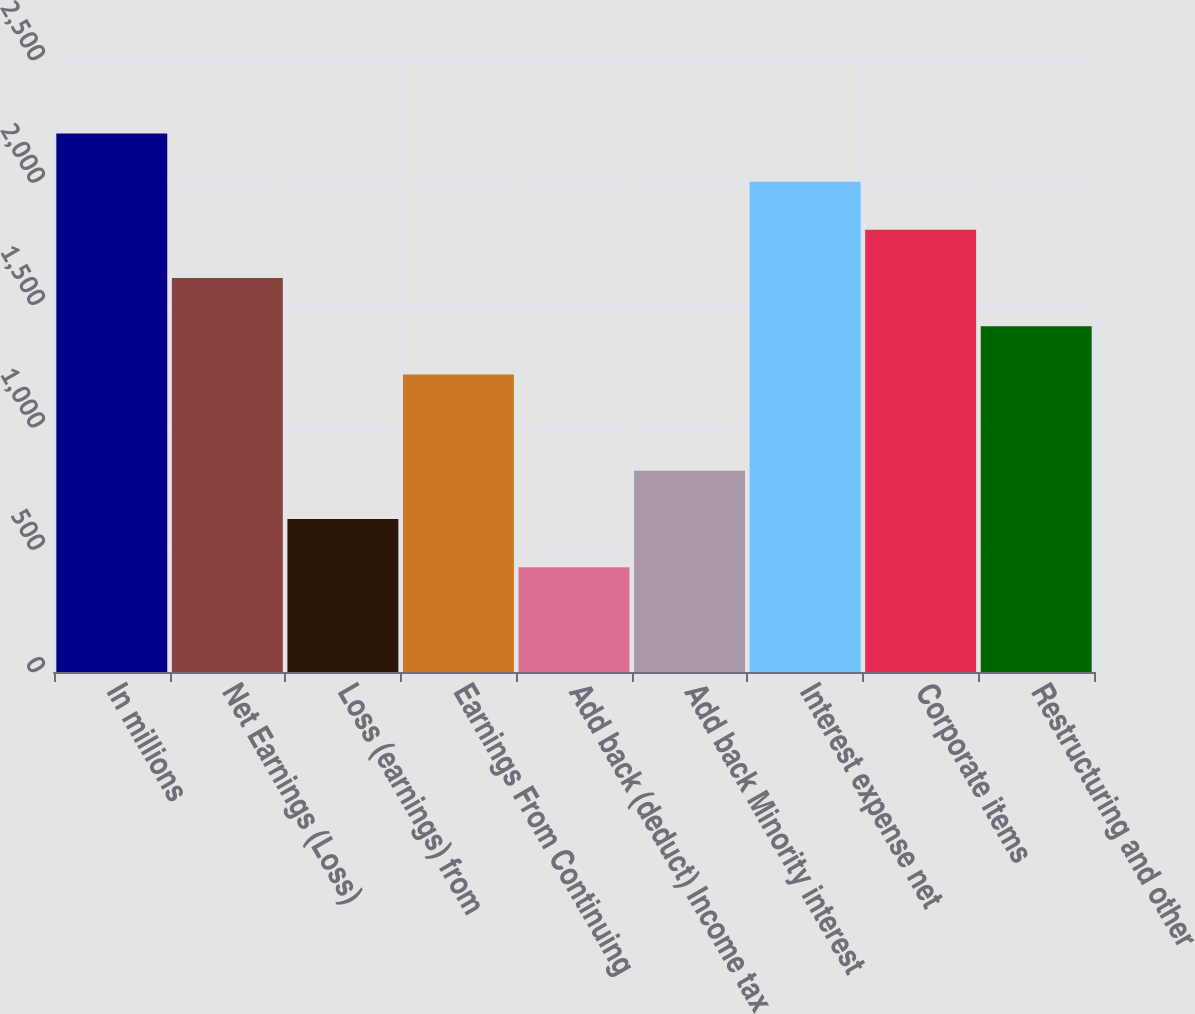Convert chart. <chart><loc_0><loc_0><loc_500><loc_500><bar_chart><fcel>In millions<fcel>Net Earnings (Loss)<fcel>Loss (earnings) from<fcel>Earnings From Continuing<fcel>Add back (deduct) Income tax<fcel>Add back Minority interest<fcel>Interest expense net<fcel>Corporate items<fcel>Restructuring and other<nl><fcel>2199.9<fcel>1609.2<fcel>624.7<fcel>1215.4<fcel>427.8<fcel>821.6<fcel>2003<fcel>1806.1<fcel>1412.3<nl></chart> 